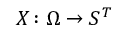<formula> <loc_0><loc_0><loc_500><loc_500>X \colon \Omega \rightarrow S ^ { T }</formula> 